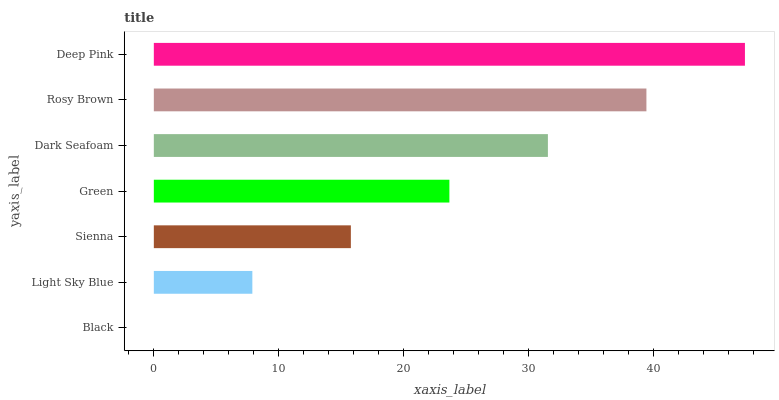Is Black the minimum?
Answer yes or no. Yes. Is Deep Pink the maximum?
Answer yes or no. Yes. Is Light Sky Blue the minimum?
Answer yes or no. No. Is Light Sky Blue the maximum?
Answer yes or no. No. Is Light Sky Blue greater than Black?
Answer yes or no. Yes. Is Black less than Light Sky Blue?
Answer yes or no. Yes. Is Black greater than Light Sky Blue?
Answer yes or no. No. Is Light Sky Blue less than Black?
Answer yes or no. No. Is Green the high median?
Answer yes or no. Yes. Is Green the low median?
Answer yes or no. Yes. Is Rosy Brown the high median?
Answer yes or no. No. Is Light Sky Blue the low median?
Answer yes or no. No. 